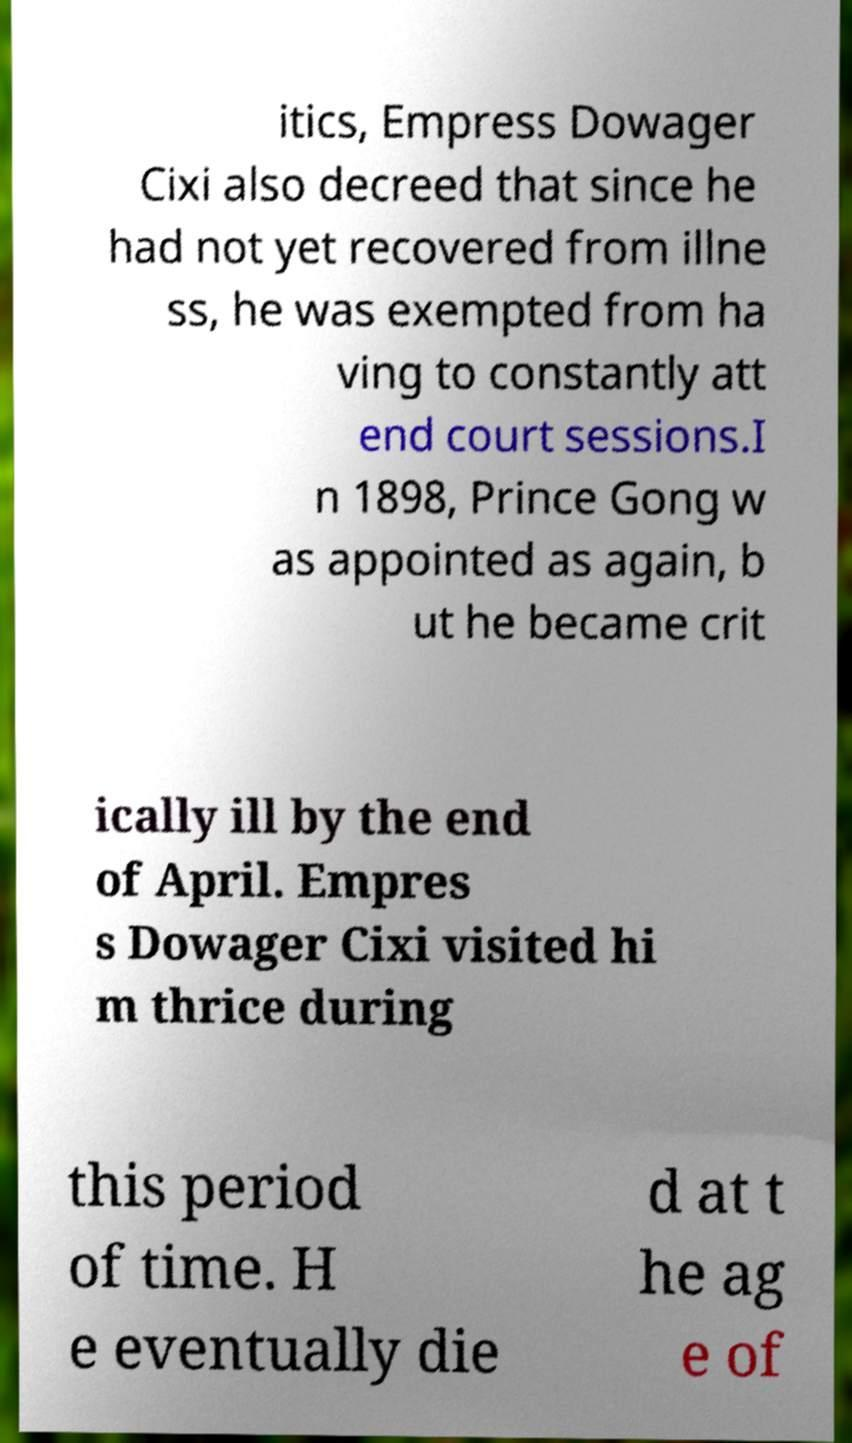Can you accurately transcribe the text from the provided image for me? itics, Empress Dowager Cixi also decreed that since he had not yet recovered from illne ss, he was exempted from ha ving to constantly att end court sessions.I n 1898, Prince Gong w as appointed as again, b ut he became crit ically ill by the end of April. Empres s Dowager Cixi visited hi m thrice during this period of time. H e eventually die d at t he ag e of 